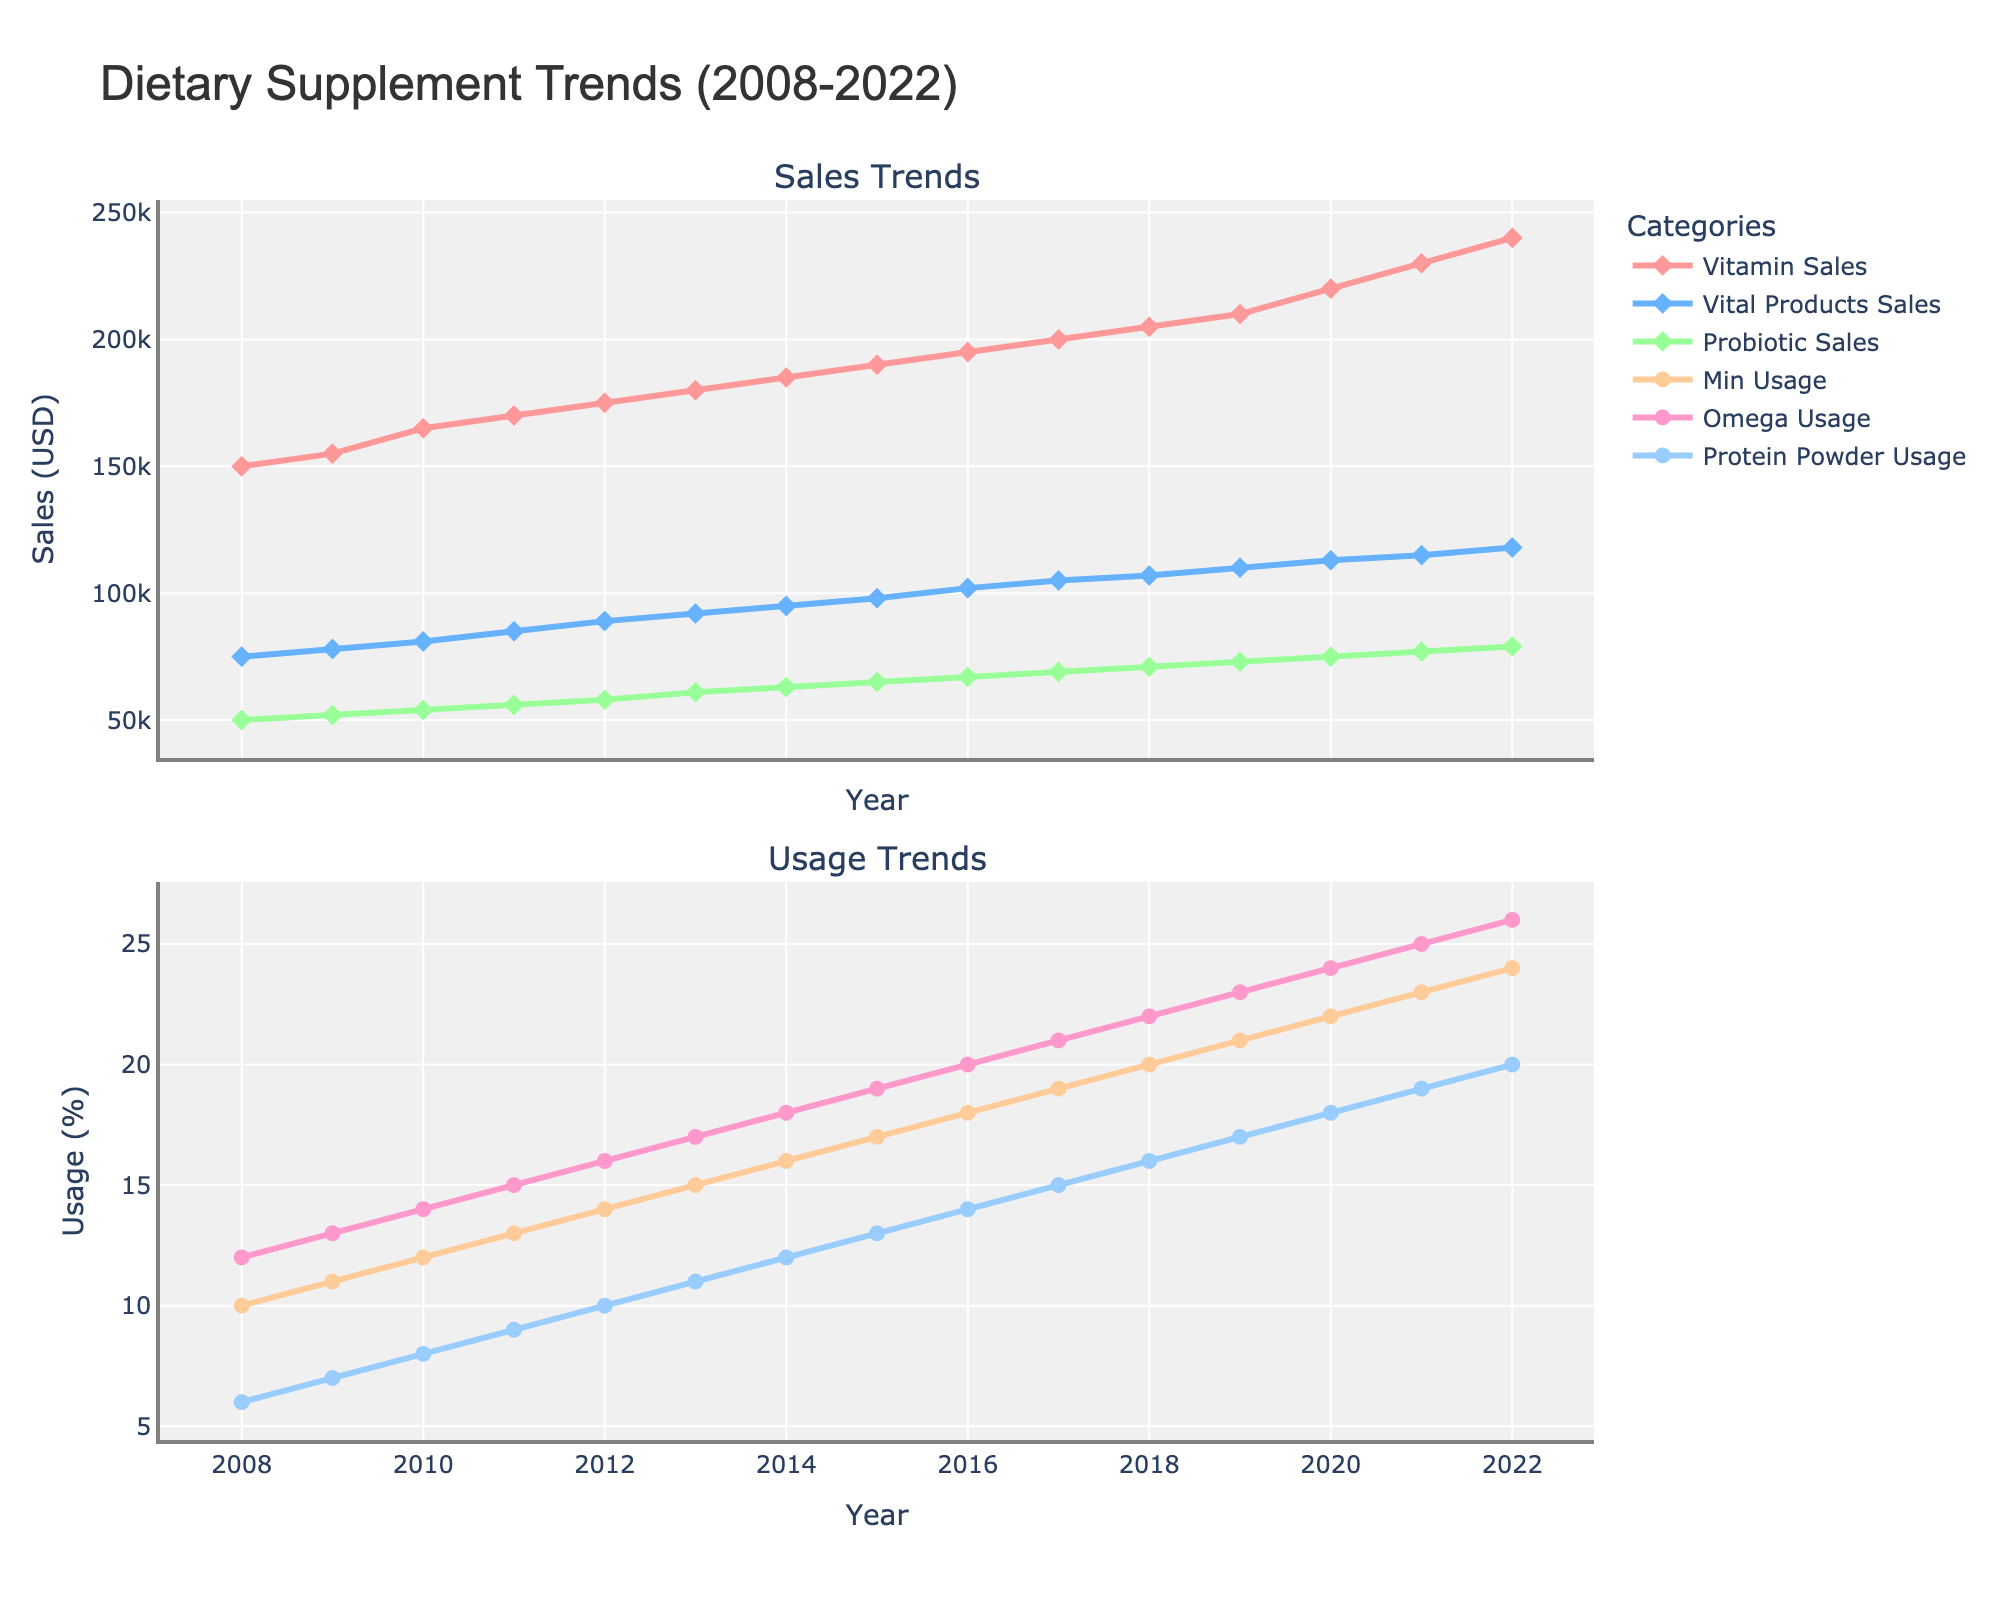Which supplement had the highest sales in 2022? Looking at the first subplot for sales data, the Vitamin Sales line reaches the highest point in 2022 compared to other supplements.
Answer: Vitamin Sales How much did the Probiotic Sales increase from 2008 to 2022? From the first subplot, in 2008 Probiotic Sales were at 50,000 and in 2022 they reached 79,000, thus the increase is 79,000 - 50,000 = 29,000.
Answer: 29,000 Which year saw the highest increase in Omega Usage? By comparing consecutive points on the Omega Usage line in the second subplot, the largest yearly increase appears between 2020 (24%) and 2021 (25%), thus it is 2021.
Answer: 2021 What were the sales of Vital Products in 2015? In the first subplot, the point on the Vital Products Sales line at the year 2015 corresponds to 98,000.
Answer: 98,000 How does the trend in Vitamin Sales compare to the trend in Omega Usage? Vitamin Sales in the first subplot show a steady upward trend, similarly the Omega Usage in the second subplot shows a steady increase over time. Both have a consistent upward trend.
Answer: Both trends steadily increased What was the combined usage percentage of Protein Powder and Omega in 2010? In the second subplot, Protein Powder Usage is 8% and Omega Usage is 14% in 2010. Combined, it is 8 + 14 = 22%.
Answer: 22% Which category had the smallest increase in usage from 2015 to 2022? By comparing the lines in the second subplot from 2015 to 2022, Mineral Usage increased from 17% to 24%, Omega Usage from 19% to 26%, and Protein Powder Usage from 13% to 20%. Mineral Usage increased by 7% which is the smallest.
Answer: Mineral Usage How did Probiotic Sales change in the first five years? The Probiotic Sales line in the first subplot goes from 50,000 in 2008 to 58,000 in 2012, an increase of 8,000 over five years.
Answer: Increased by 8,000 What was the overall trend of Vitamin Sales and Protein Powder Usage from 2008 to 2022? Both Vitamin Sales and Protein Powder Usage lines show a consistent upward trend in their respective subplots throughout the 15 years.
Answer: Consistent upward trend 